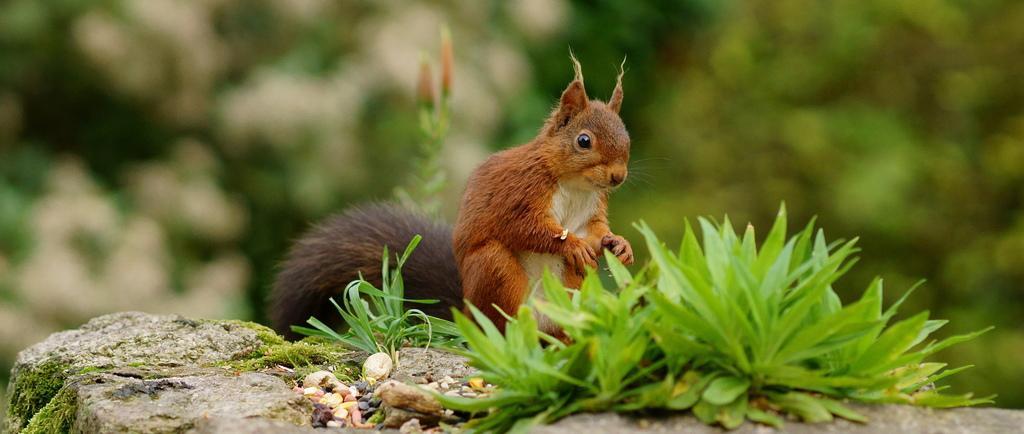Could you give a brief overview of what you see in this image? In this image I can see the grass, I can see the stone. I can see an animal. In the background, I can see the trees. 